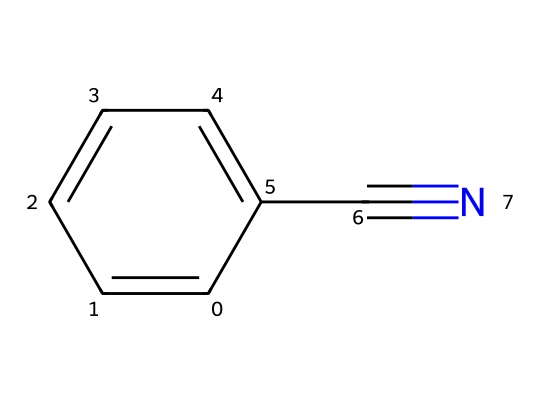What is the common name for this chemical? The SMILES representation includes "C#N," indicating a nitrile group attached to a benzene ring. This structure corresponds to benzonitrile, which is the common name for this chemical.
Answer: benzonitrile How many carbon atoms are in benzonitrile? In the chemical structure, there are six carbon atoms in the benzene ring and one additional carbon in the nitrile group. Adding them together gives a total of seven carbon atoms.
Answer: seven What type of functional group is present in benzonitrile? The nitrile group, indicated by "C#N" in the SMILES representation, is the functional group present in this chemical.
Answer: nitrile How many hydrogen atoms are in benzonitrile? The benzene ring has five hydrogen atoms (since one hydrogen is replaced by the nitrile group). Therefore, the total number of hydrogen atoms in benzonitrile is five.
Answer: five Why is benzonitrile significant in dye production? Benzonitrile serves as a precursor in the synthesis of various dyes due to the reactivity of its nitrile group, which can undergo transformations to create colored compounds.
Answer: precursor What type of chemical bond connects the carbon and nitrogen atoms in the nitrile? The bond between the carbon and nitrogen in the nitrile group is a triple bond, as indicated by the "#", which denotes multiple bonding in the SMILES notation.
Answer: triple bond 